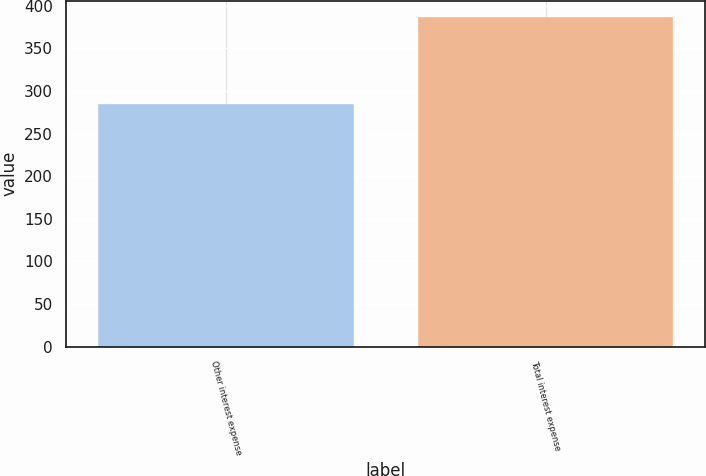<chart> <loc_0><loc_0><loc_500><loc_500><bar_chart><fcel>Other interest expense<fcel>Total interest expense<nl><fcel>285<fcel>387<nl></chart> 